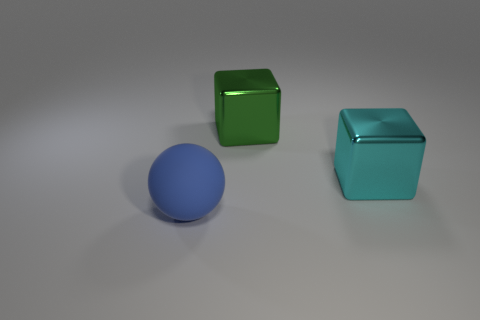What number of other things are there of the same shape as the large blue thing?
Your response must be concise. 0. How many green metallic cubes are behind the cube that is behind the metal thing that is on the right side of the green metallic object?
Keep it short and to the point. 0. What number of green shiny objects have the same shape as the big cyan thing?
Offer a very short reply. 1. There is a metallic thing behind the large cube that is in front of the big thing that is behind the big cyan metal object; what shape is it?
Offer a very short reply. Cube. Do the blue matte ball and the metal object behind the big cyan thing have the same size?
Provide a succinct answer. Yes. Is there a blue matte thing that has the same size as the cyan object?
Give a very brief answer. Yes. How many other things are there of the same material as the big green thing?
Your answer should be very brief. 1. What color is the object that is on the left side of the big cyan metal object and behind the large matte thing?
Offer a terse response. Green. Is the thing to the right of the green cube made of the same material as the thing that is behind the cyan metallic cube?
Make the answer very short. Yes. There is a big rubber thing; is it the same color as the thing that is right of the green metal thing?
Provide a short and direct response. No. 